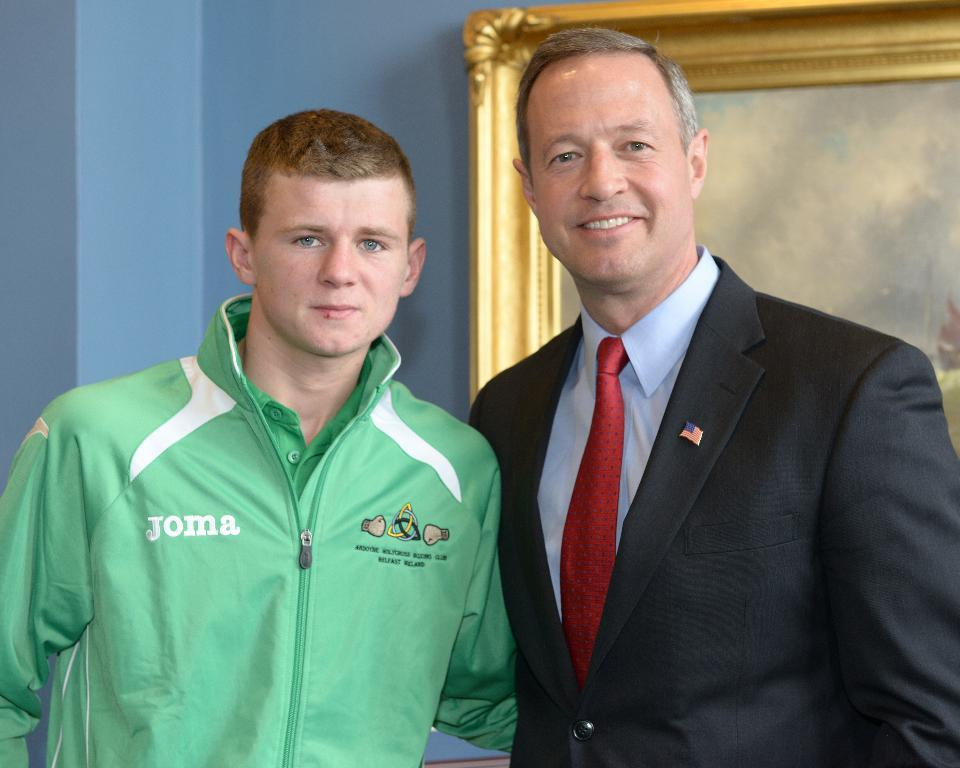Provide a one-sentence caption for the provided image. Two men are looking at the camera, and one of them is wearing a Joma jacket. 